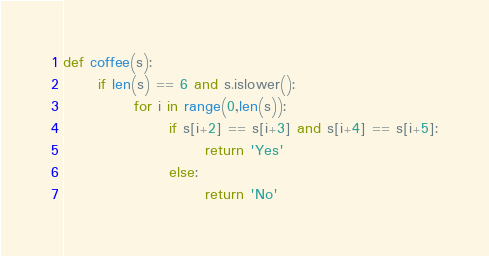Convert code to text. <code><loc_0><loc_0><loc_500><loc_500><_Python_>def coffee(s):
      if len(s) == 6 and s.islower():
            for i in range(0,len(s)):
                  if s[i+2] == s[i+3] and s[i+4] == s[i+5]:
                        return 'Yes'
                  else:
                        return 'No'</code> 